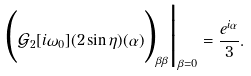<formula> <loc_0><loc_0><loc_500><loc_500>\Big ( \mathcal { G } _ { 2 } [ i \omega _ { 0 } ] ( 2 \sin \eta ) ( \alpha ) \Big ) _ { \beta \beta } \Big | _ { \beta = 0 } = \frac { e ^ { i \alpha } } { 3 } .</formula> 